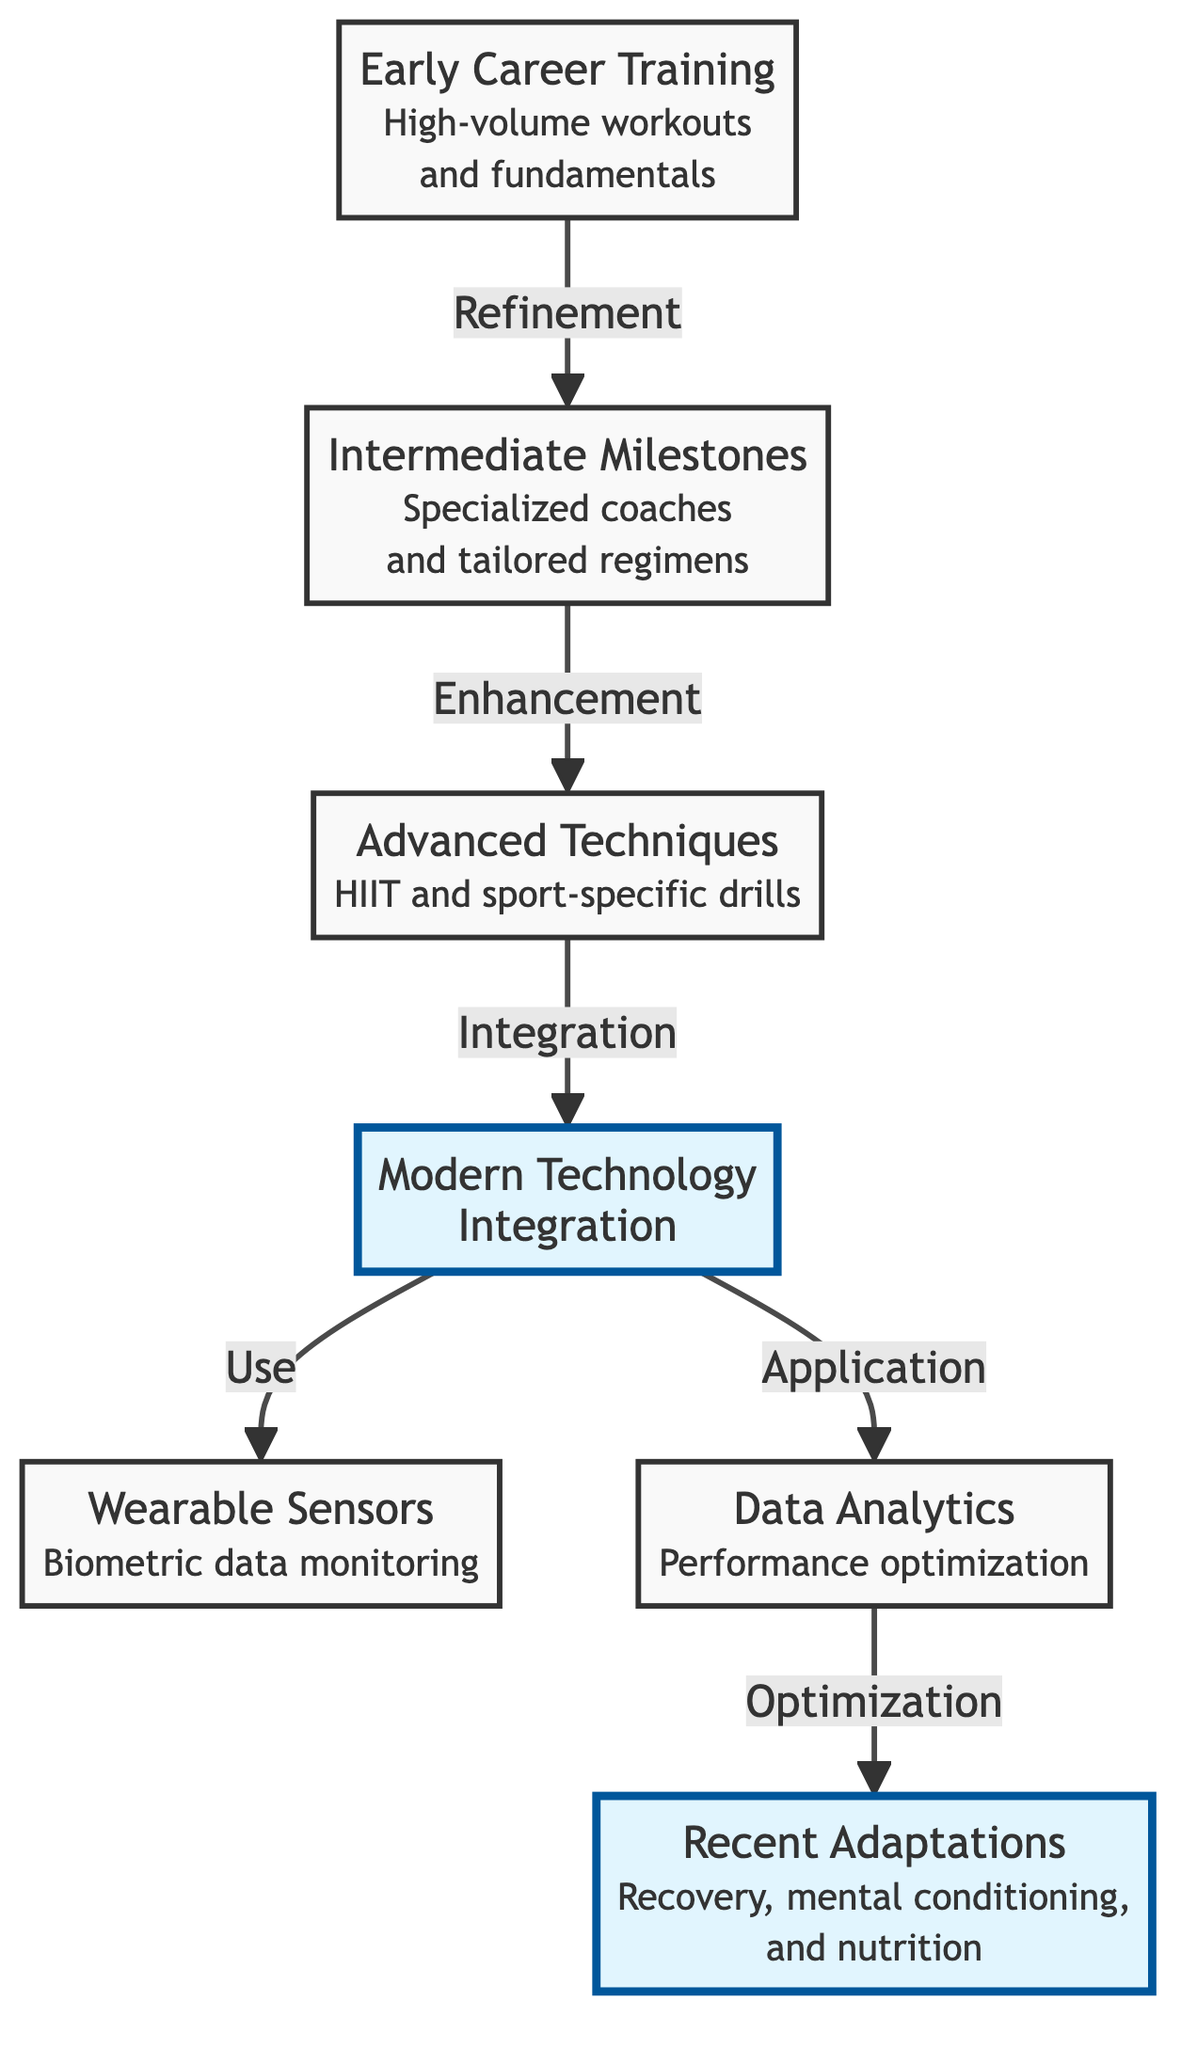What is the first training technique highlighted in the diagram? The first training technique is "Early Career Training," which is shown as the starting point of the diagram. This is established by identifying the initial node in the flowchart.
Answer: Early Career Training How many total nodes are present in the diagram? The diagram consists of seven nodes, which are individually outlined as distinct training phases, and counted sequentially from the beginning to the end of the flow.
Answer: 7 What training technique comes after 'Intermediate Milestones'? According to the flow from 'Intermediate Milestones', the next technique is 'Advanced Techniques,' as indicated by the directed edge connecting these two nodes in the diagram.
Answer: Advanced Techniques Which training technique involves wearable sensors? The training technique that involves wearable sensors is identified as 'Wearable Sensors,' which is specifically mentioned as part of the fourth node configuration.
Answer: Wearable Sensors What is the relationship between 'Modern Technology' and 'Data Analytics'? The relationship between 'Modern Technology' and 'Data Analytics' is that 'Modern Technology' leads to both 'Wearable Sensors' and 'Data Analytics', indicating that both applications can stem from technological advancements noted in the diagram.
Answer: Integration Which phase focuses on recovery, mental conditioning, and nutrition? The phase that focuses on recovery, mental conditioning, and nutrition is labeled as 'Recent Adaptations,' located at the end of the flowchart.
Answer: Recent Adaptations What change is signified by the arrow from 'Advanced Techniques' to 'Modern Technology'? The arrow signifies 'Integration,' showing that 'Advanced Techniques' and 'Modern Technology' are interconnected, reflecting the evolution of training methods through the application of technology.
Answer: Integration What is the common theme among the final phases of the diagram? The common theme among the final phases, 'Modern Technology', 'Wearable Sensors', 'Data Analytics', and 'Recent Adaptations', is an emphasis on technological advancements and optimization strategies in training.
Answer: Technology and Optimization 